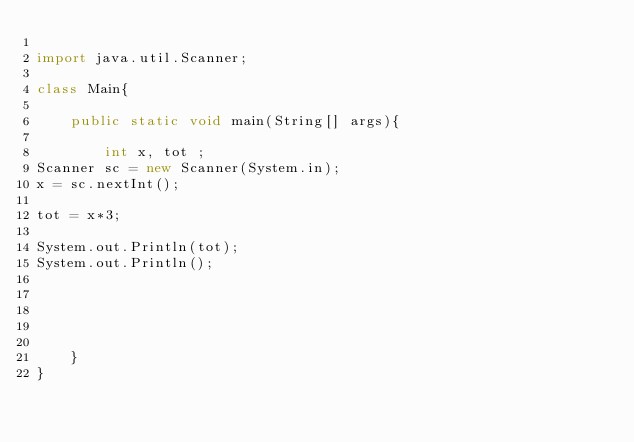<code> <loc_0><loc_0><loc_500><loc_500><_Java_>
import java.util.Scanner;

class Main{

    public static void main(String[] args){
        
        int x, tot ;
Scanner sc = new Scanner(System.in);
x = sc.nextInt();

tot = x*3;

System.out.Println(tot);
System.out.Println();





    }
}</code> 